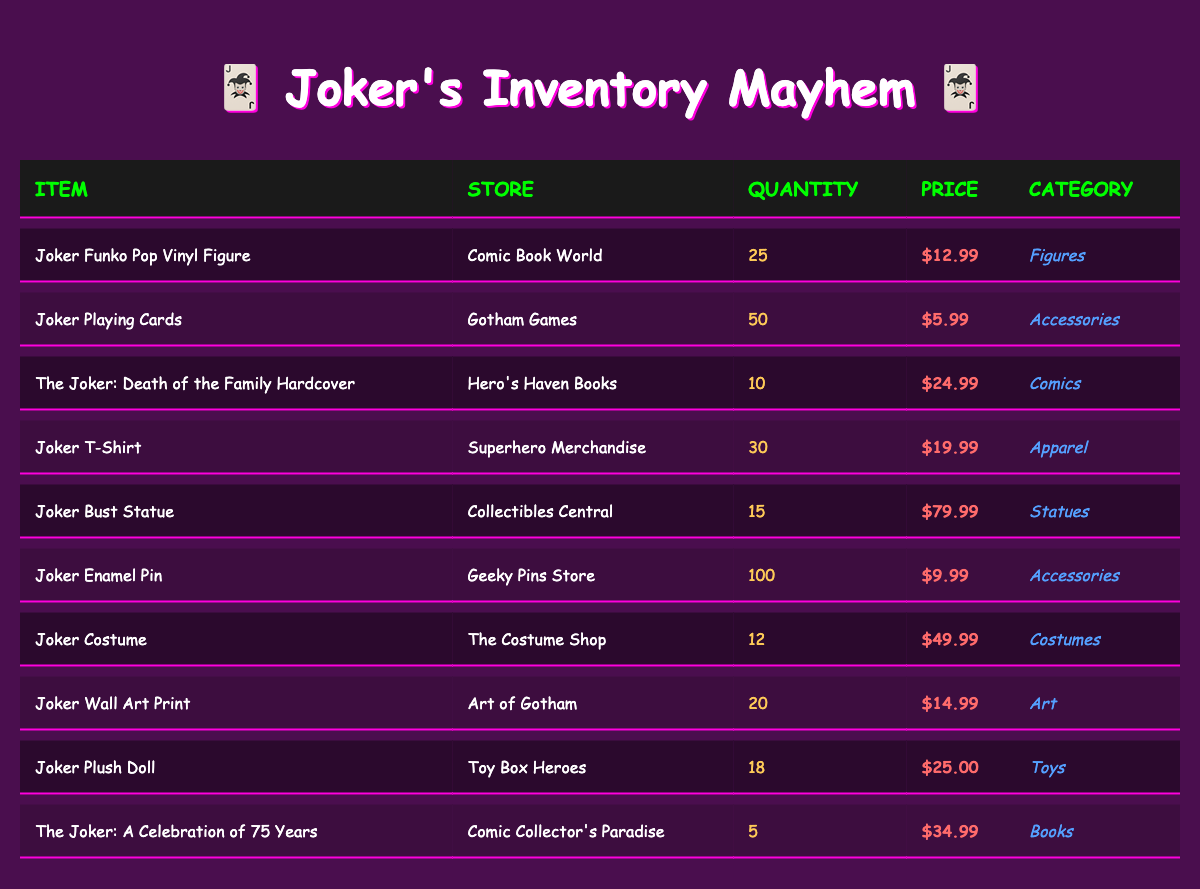What is the quantity of Joker Funko Pop Vinyl Figures available? The table shows that the quantity of Joker Funko Pop Vinyl Figures in Comic Book World is 25.
Answer: 25 How much does the Joker Bust Statue cost? According to the table, the price of the Joker Bust Statue at Collectibles Central is $79.99.
Answer: 79.99 Which store has the most Joker-themed items in stock? By evaluating the quantities, Gotham Games has 50 Joker Playing Cards, which is the highest quantity among the items listed, indicating it has the most stock.
Answer: Gotham Games Is there a Joker Costume available in stock? The table indicates that there is a Joker Costume with a quantity of 12, therefore the answer is yes.
Answer: Yes What is the total quantity of Joker accessories available? The accessories listed are Joker Playing Cards (50), Joker Enamel Pin (100). Adding these quantities gives 50 + 100 = 150.
Answer: 150 How much would it cost to buy all the Joker Playing Cards and Joker Enamel Pins? For the Joker Playing Cards, the cost is $5.99, and for the Joker Enamel Pin, it's $9.99. Thus, the total cost for 50 playing cards is 50 * 5.99 = 299.50, and for 100 pins it's 100 * 9.99 = 999. Adding the two totals gives 299.50 + 999 = 1298.50.
Answer: 1298.50 Are there more Joker-themed apparel items than statues? The Jokers T-Shirts have a quantity of 30, while the Joker Bust Statue has a quantity of 15. Since 30 is greater than 15, the answer is yes.
Answer: Yes Which item has the highest price? The table lists the Joker Bust Statue at $79.99, which is higher than any other items, making it the most expensive.
Answer: Joker Bust Statue What is the average price of Joker collectibles in this inventory? Total prices: (12.99 + 5.99 + 24.99 + 19.99 + 79.99 + 9.99 + 49.99 + 14.99 + 25.00 + 34.99) =  353.90. There are 10 items total. The average price is 353.90 / 10 = 35.39.
Answer: 35.39 